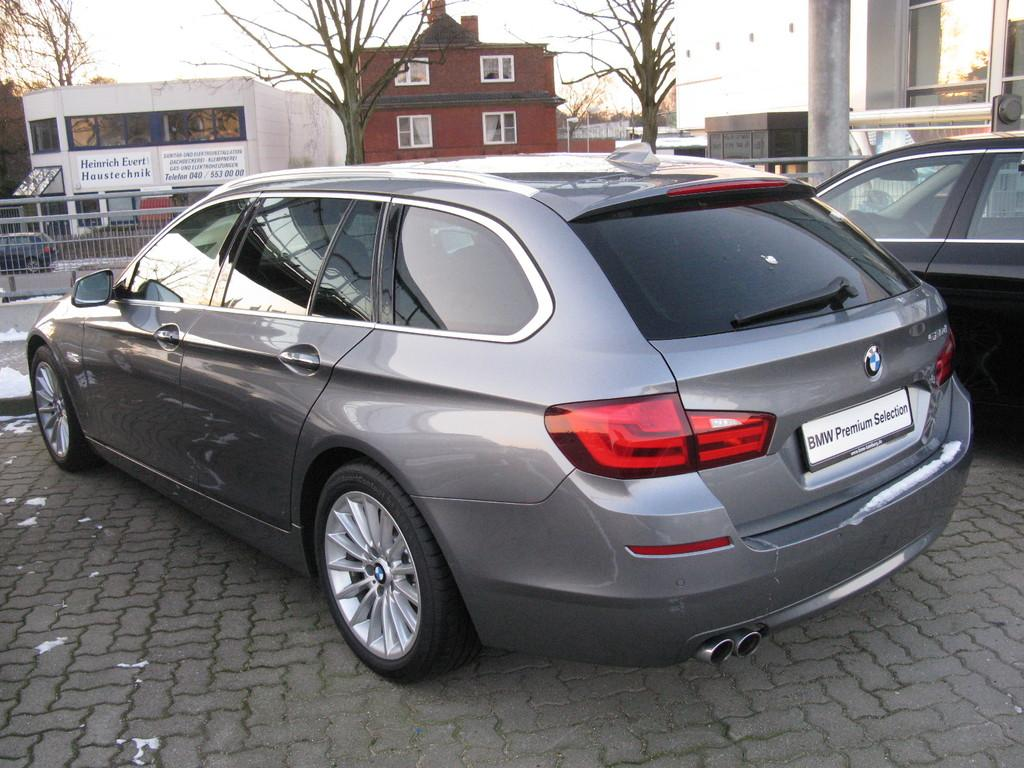What is the main subject of the image? The main subject of the image is cars on a road. What is in front of the cars? There is a fencing in front of the cars. What can be seen in the background of the image? There are trees and buildings in the background of the image. What type of picture is hanging on the wall in the image? There is no mention of a picture hanging on the wall in the image; the main subjects are cars on a road, a fencing, trees, and buildings in the background. 